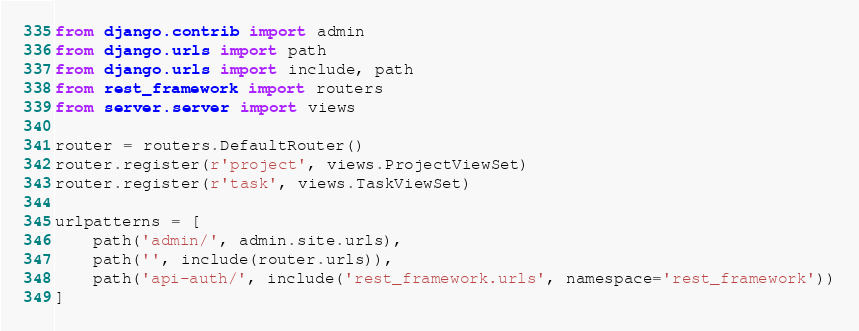Convert code to text. <code><loc_0><loc_0><loc_500><loc_500><_Python_>from django.contrib import admin
from django.urls import path
from django.urls import include, path
from rest_framework import routers
from server.server import views

router = routers.DefaultRouter()
router.register(r'project', views.ProjectViewSet)
router.register(r'task', views.TaskViewSet)

urlpatterns = [
    path('admin/', admin.site.urls),
    path('', include(router.urls)),
    path('api-auth/', include('rest_framework.urls', namespace='rest_framework'))
]
</code> 